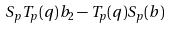<formula> <loc_0><loc_0><loc_500><loc_500>S _ { p } T _ { p } ( q ) b _ { 2 } - T _ { p } ( q ) S _ { p } ( b )</formula> 